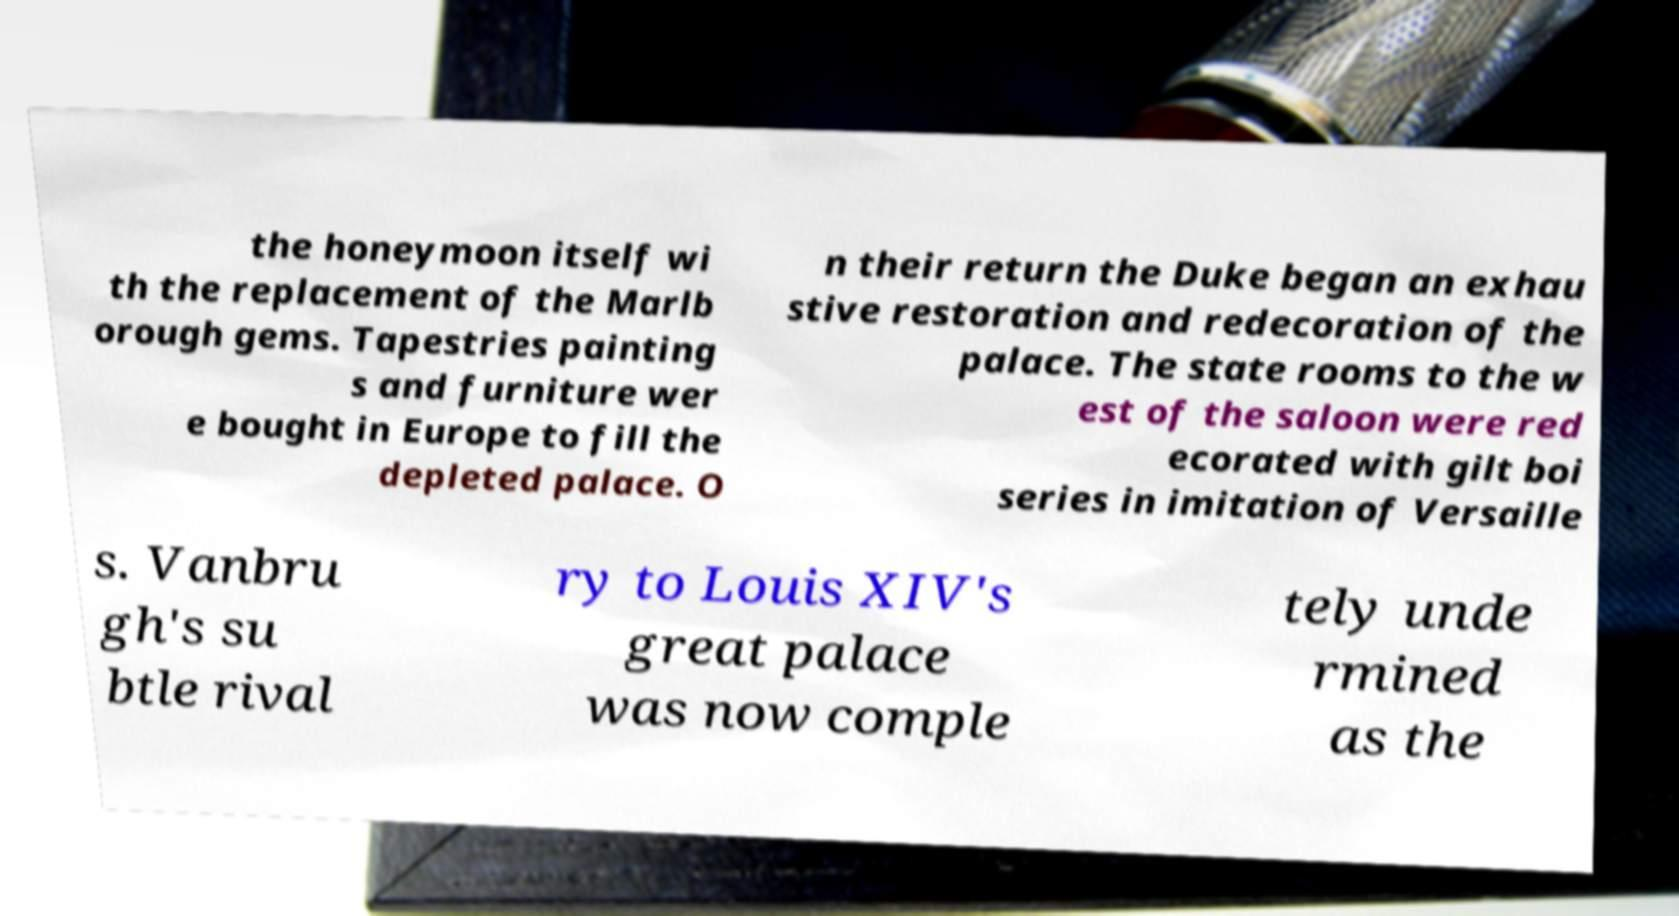Could you assist in decoding the text presented in this image and type it out clearly? the honeymoon itself wi th the replacement of the Marlb orough gems. Tapestries painting s and furniture wer e bought in Europe to fill the depleted palace. O n their return the Duke began an exhau stive restoration and redecoration of the palace. The state rooms to the w est of the saloon were red ecorated with gilt boi series in imitation of Versaille s. Vanbru gh's su btle rival ry to Louis XIV's great palace was now comple tely unde rmined as the 